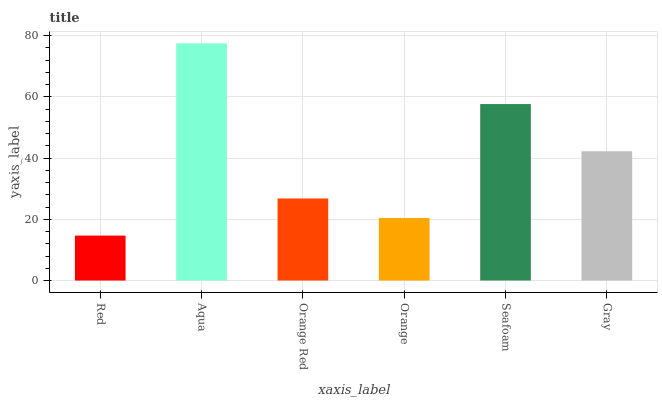Is Red the minimum?
Answer yes or no. Yes. Is Aqua the maximum?
Answer yes or no. Yes. Is Orange Red the minimum?
Answer yes or no. No. Is Orange Red the maximum?
Answer yes or no. No. Is Aqua greater than Orange Red?
Answer yes or no. Yes. Is Orange Red less than Aqua?
Answer yes or no. Yes. Is Orange Red greater than Aqua?
Answer yes or no. No. Is Aqua less than Orange Red?
Answer yes or no. No. Is Gray the high median?
Answer yes or no. Yes. Is Orange Red the low median?
Answer yes or no. Yes. Is Orange Red the high median?
Answer yes or no. No. Is Aqua the low median?
Answer yes or no. No. 